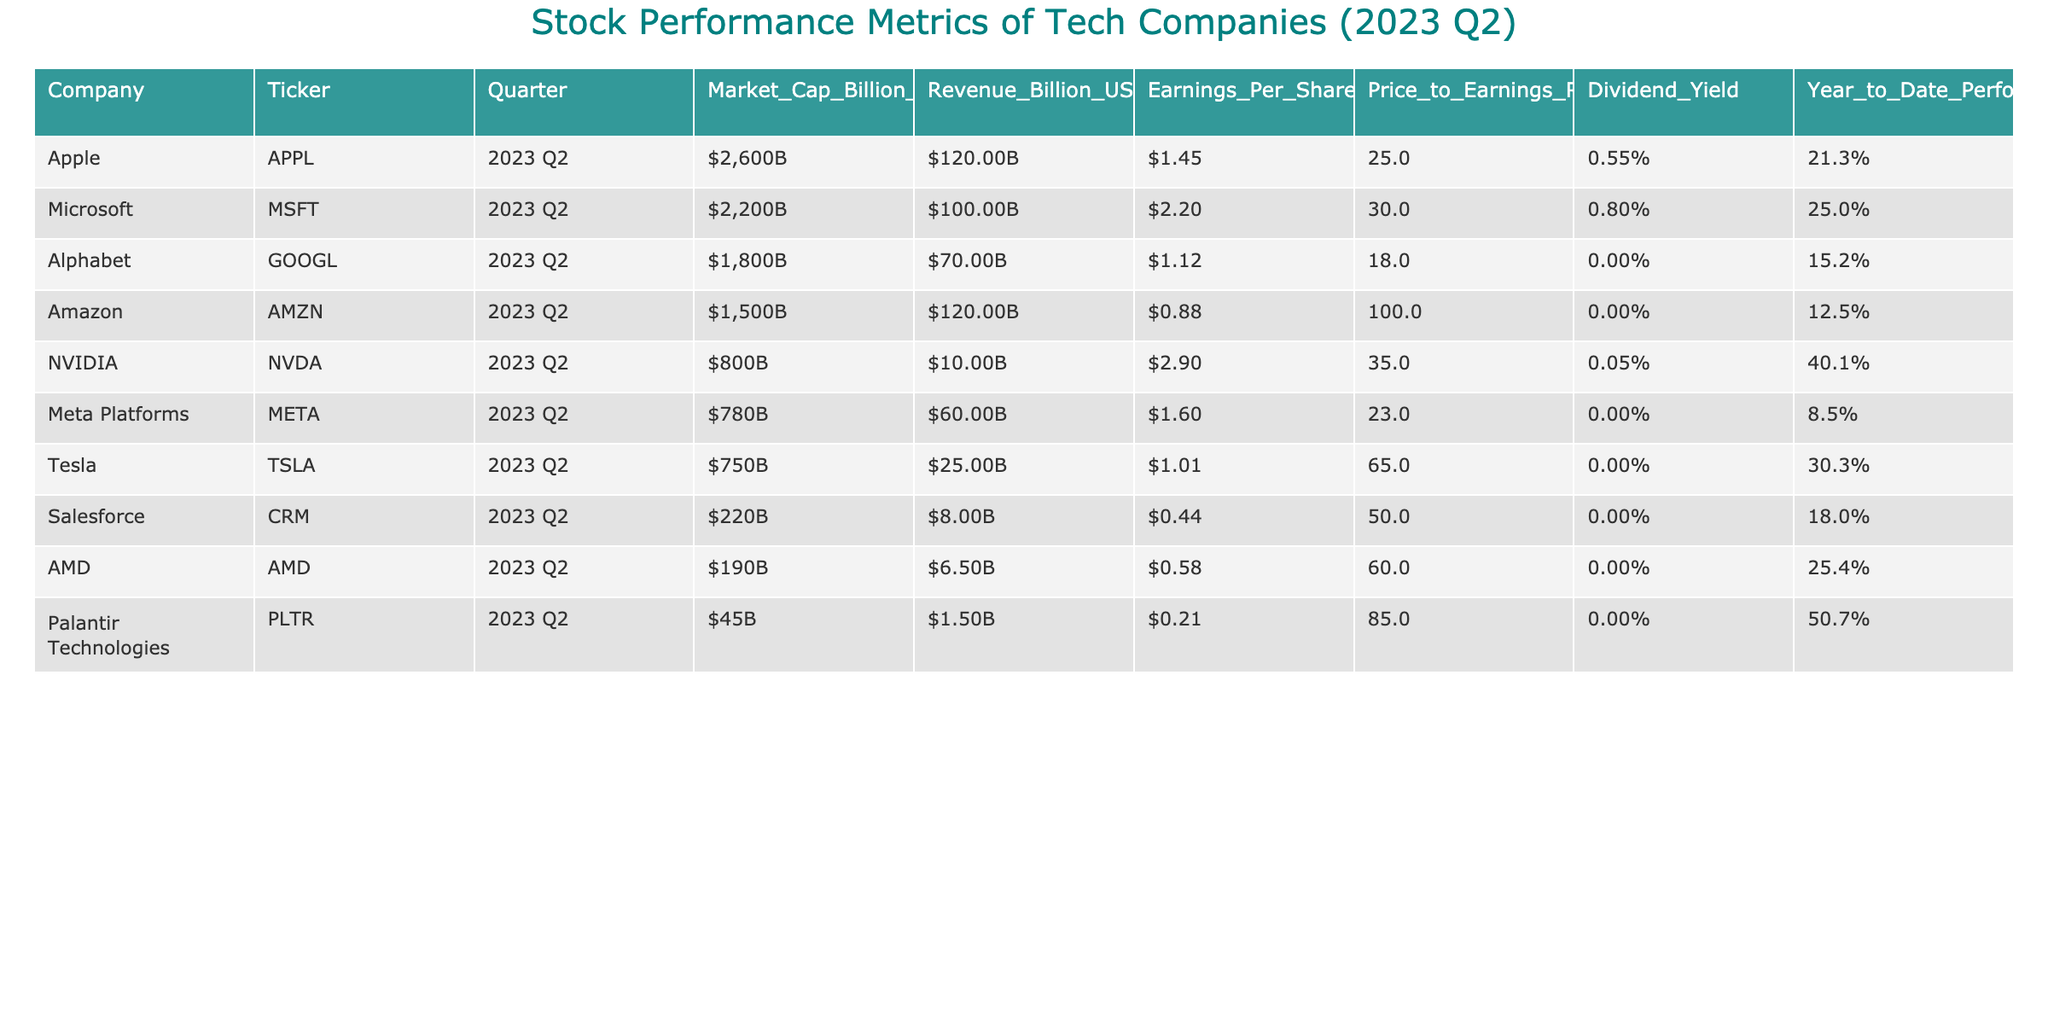What is the market cap of NVIDIA? The market cap of NVIDIA, as listed in the table, is $800 billion.
Answer: $800B Which company has the highest Price to Earnings Ratio? Reviewing the table, Amazon has the highest Price to Earnings Ratio of 100.0.
Answer: Amazon What is the average dividend yield of the companies listed? The dividend yields for the companies are 0.55%, 0.80%, 0.00%, 0.00%, 0.05%, 0.00%, 0.00%, 0.00%, and 0.00%. Adding those up gives 1.40% and dividing by 9 gives an average of 0.155%.
Answer: 0.16% Is Tesla's Year to Date Performance above 30%? Tesla's Year to Date Performance is 30.3%, which is indeed above 30%.
Answer: Yes Which company has the lowest earnings per share? Looking at the table, Salesforce has the lowest earnings per share at $0.44.
Answer: Salesforce If we sum the revenues of all companies, what is the total revenue? The revenues for the companies are $120.00B, $100.00B, $70.00B, $120.00B, $10.00B, $60.00B, $25.00B, $8.00B, and $6.50B. Adding these gives a total of $519.50 billion.
Answer: $519.50B What is the dividend yield of Alphabet? Alphabet's dividend yield is reported as 0.00%, indicating no dividends are paid.
Answer: 0.00% Is the Year to Date Performance of Palantir Technologies higher than that of Meta Platforms? Palantir Technologies has a Year to Date Performance of 50.7%, while Meta Platforms has 8.5%. Since 50.7% is greater than 8.5%, the answer is yes.
Answer: Yes What is the difference in market cap between Apple and Meta Platforms? The market cap of Apple is $2600 billion, and Meta Platforms is $780 billion. The difference is $2600B - $780B = $1820B.
Answer: $1820B How many companies have a market cap of less than $500 billion? The companies with market caps below $500 billion are Salesforce ($220B), AMD ($190B), and Palantir Technologies ($45B), totaling 3 companies.
Answer: 3 